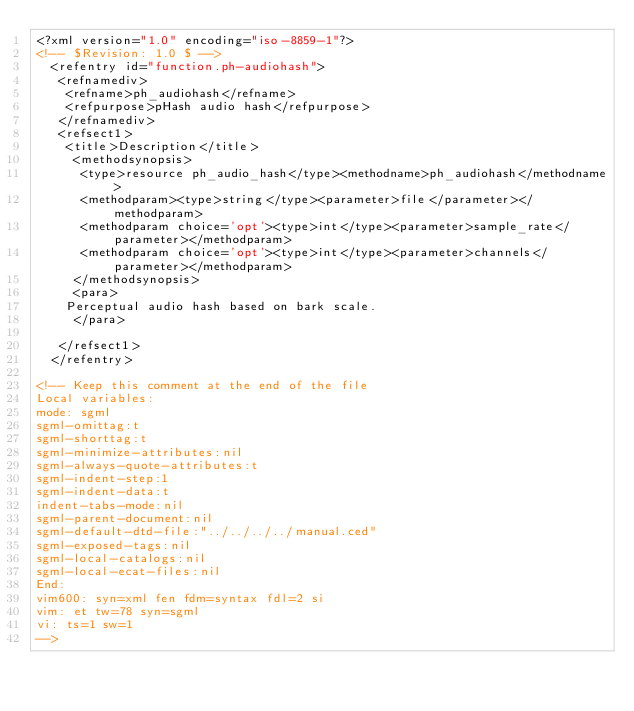Convert code to text. <code><loc_0><loc_0><loc_500><loc_500><_XML_><?xml version="1.0" encoding="iso-8859-1"?>
<!-- $Revision: 1.0 $ -->
  <refentry id="function.ph-audiohash">
   <refnamediv>
    <refname>ph_audiohash</refname>
    <refpurpose>pHash audio hash</refpurpose>
   </refnamediv>
   <refsect1>
    <title>Description</title>
     <methodsynopsis>
      <type>resource ph_audio_hash</type><methodname>ph_audiohash</methodname>
      <methodparam><type>string</type><parameter>file</parameter></methodparam>
      <methodparam choice='opt'><type>int</type><parameter>sample_rate</parameter></methodparam>
      <methodparam choice='opt'><type>int</type><parameter>channels</parameter></methodparam>
     </methodsynopsis>
     <para>
	Perceptual audio hash based on bark scale.
     </para>

   </refsect1>
  </refentry>

<!-- Keep this comment at the end of the file
Local variables:
mode: sgml
sgml-omittag:t
sgml-shorttag:t
sgml-minimize-attributes:nil
sgml-always-quote-attributes:t
sgml-indent-step:1
sgml-indent-data:t
indent-tabs-mode:nil
sgml-parent-document:nil
sgml-default-dtd-file:"../../../../manual.ced"
sgml-exposed-tags:nil
sgml-local-catalogs:nil
sgml-local-ecat-files:nil
End:
vim600: syn=xml fen fdm=syntax fdl=2 si
vim: et tw=78 syn=sgml
vi: ts=1 sw=1
-->
</code> 